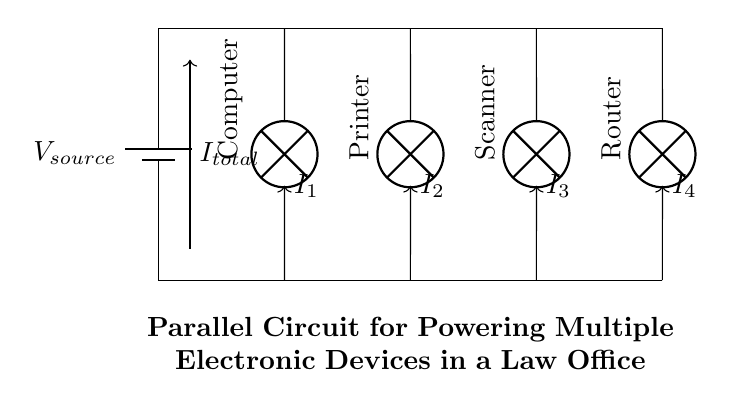What is the source voltage? The source voltage is indicated at the battery in the circuit diagram. There’s no specific value shown, so we refer to it generally as V source.
Answer: V source How many devices are connected in parallel? The circuit diagram shows four devices connected in parallel, each represented by a lamp symbol. They are a computer, printer, scanner, and router.
Answer: Four What does the total current represent? The total current, labeled I total in the circuit, represents the sum of the currents flowing through each device connected in parallel. It can be calculated as I total = I 1 + I 2 + I 3 + I 4.
Answer: I total Which component has the highest current? In a parallel circuit, the component with the lowest resistance typically draws the highest current. Since resistance values are not provided, we can't definitively answer, but generally, devices with more power consumption draw higher currents.
Answer: Depends on resistance What is the relationship between the current in each branch and total current? The total current entering the parallel circuit is equal to the sum of the currents through each parallel branch: I total = I 1 + I 2 + I 3 + I 4. This follows the principle of conservation of charge.
Answer: Sum of branch currents What happens if one device fails in this circuit? If one device in a parallel circuit fails, the other devices remain operational because they are not dependent on the failed device for current supply. The total current will decrease, but the other branches still function normally.
Answer: Other devices operate 